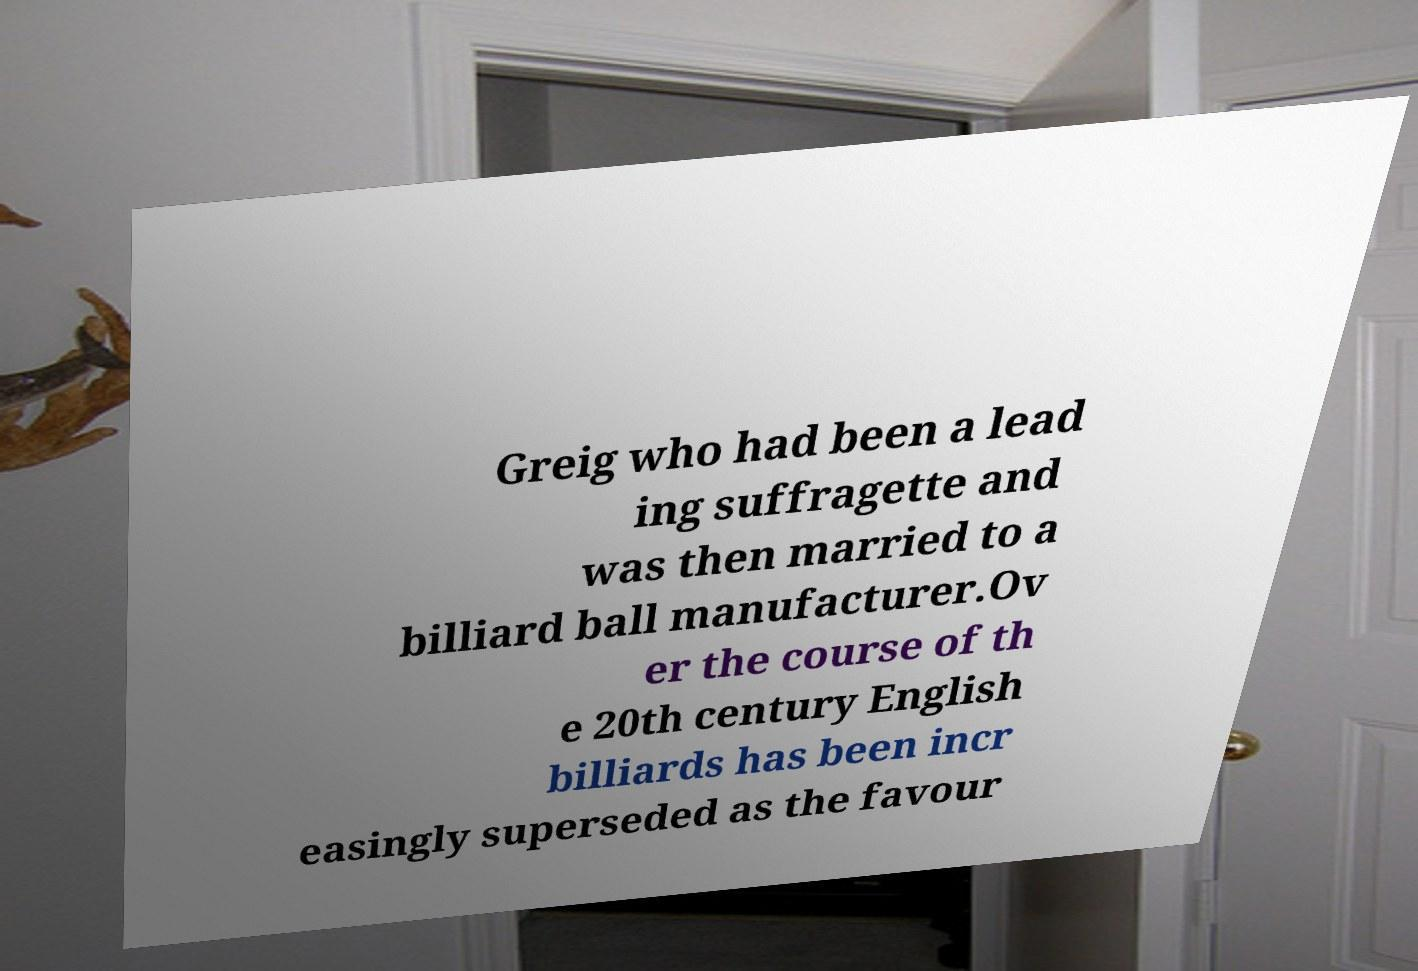Please read and relay the text visible in this image. What does it say? Greig who had been a lead ing suffragette and was then married to a billiard ball manufacturer.Ov er the course of th e 20th century English billiards has been incr easingly superseded as the favour 